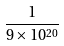<formula> <loc_0><loc_0><loc_500><loc_500>\frac { 1 } { 9 \times 1 0 ^ { 2 0 } }</formula> 